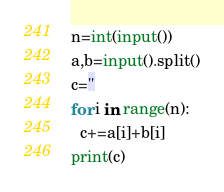Convert code to text. <code><loc_0><loc_0><loc_500><loc_500><_Python_>n=int(input())
a,b=input().split()
c=''
for i in range(n):
  c+=a[i]+b[i]
print(c)</code> 